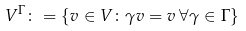<formula> <loc_0><loc_0><loc_500><loc_500>V ^ { \Gamma } \colon = \{ v \in V \colon \gamma v = v \, \forall \gamma \in \Gamma \}</formula> 